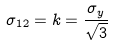<formula> <loc_0><loc_0><loc_500><loc_500>\sigma _ { 1 2 } = k = \frac { \sigma _ { y } } { \sqrt { 3 } }</formula> 